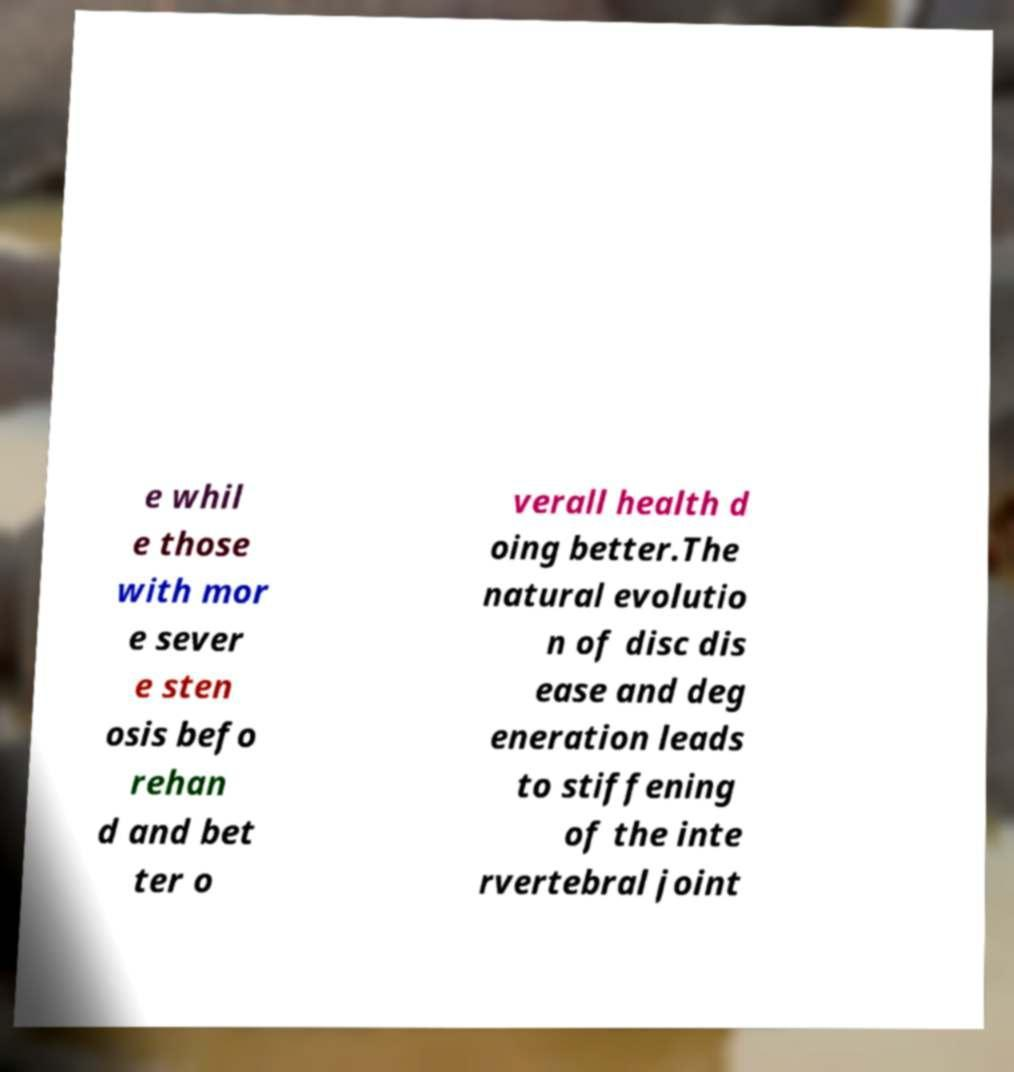What messages or text are displayed in this image? I need them in a readable, typed format. e whil e those with mor e sever e sten osis befo rehan d and bet ter o verall health d oing better.The natural evolutio n of disc dis ease and deg eneration leads to stiffening of the inte rvertebral joint 